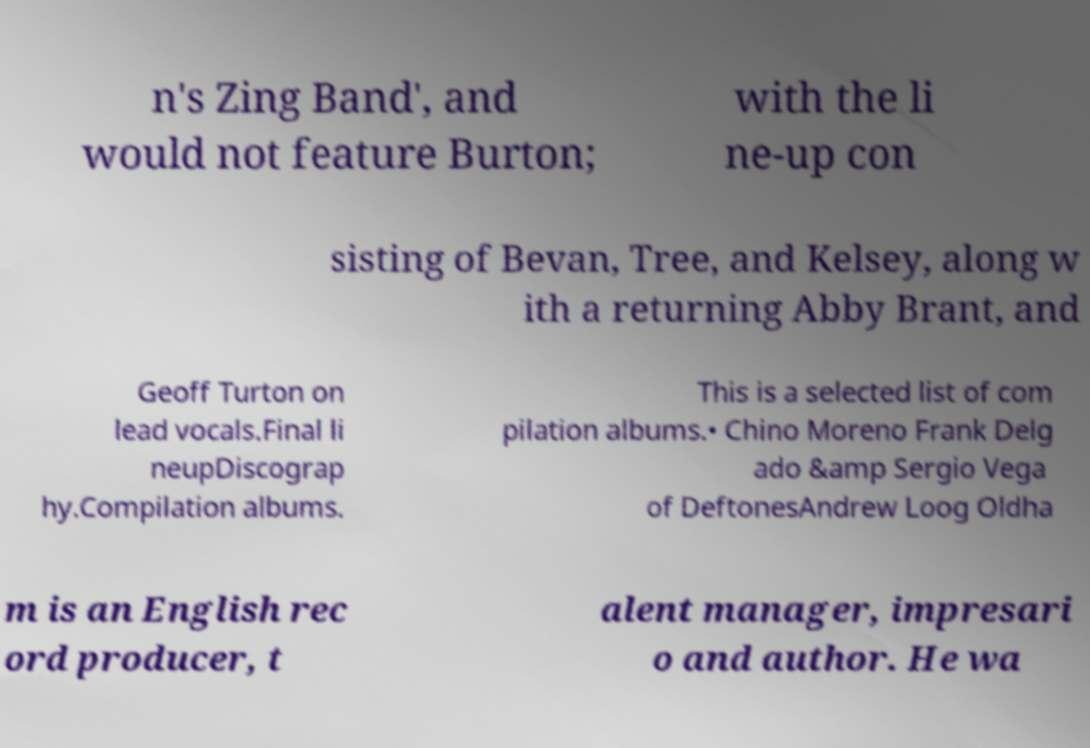Please identify and transcribe the text found in this image. n's Zing Band', and would not feature Burton; with the li ne-up con sisting of Bevan, Tree, and Kelsey, along w ith a returning Abby Brant, and Geoff Turton on lead vocals.Final li neupDiscograp hy.Compilation albums. This is a selected list of com pilation albums.• Chino Moreno Frank Delg ado &amp Sergio Vega of DeftonesAndrew Loog Oldha m is an English rec ord producer, t alent manager, impresari o and author. He wa 